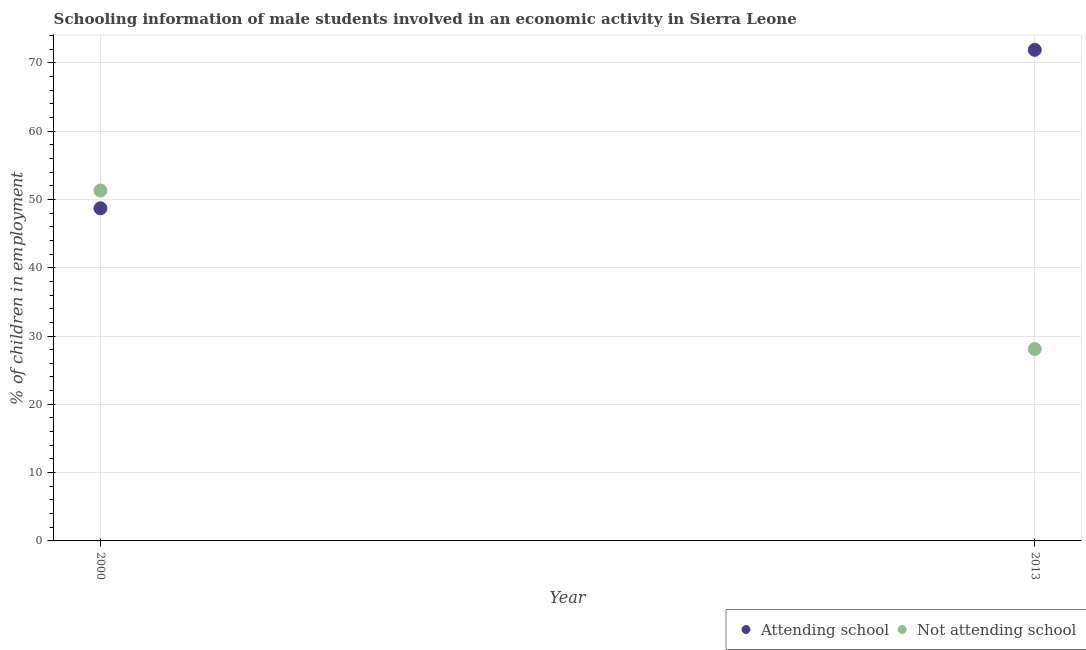How many different coloured dotlines are there?
Provide a succinct answer. 2. Is the number of dotlines equal to the number of legend labels?
Your response must be concise. Yes. What is the percentage of employed males who are attending school in 2000?
Make the answer very short. 48.7. Across all years, what is the maximum percentage of employed males who are attending school?
Ensure brevity in your answer.  71.9. Across all years, what is the minimum percentage of employed males who are attending school?
Provide a succinct answer. 48.7. In which year was the percentage of employed males who are not attending school minimum?
Your response must be concise. 2013. What is the total percentage of employed males who are not attending school in the graph?
Your response must be concise. 79.4. What is the difference between the percentage of employed males who are not attending school in 2000 and that in 2013?
Your answer should be very brief. 23.2. What is the difference between the percentage of employed males who are not attending school in 2013 and the percentage of employed males who are attending school in 2000?
Offer a very short reply. -20.6. What is the average percentage of employed males who are not attending school per year?
Your answer should be very brief. 39.7. In the year 2013, what is the difference between the percentage of employed males who are not attending school and percentage of employed males who are attending school?
Make the answer very short. -43.8. In how many years, is the percentage of employed males who are attending school greater than 10 %?
Give a very brief answer. 2. What is the ratio of the percentage of employed males who are attending school in 2000 to that in 2013?
Your response must be concise. 0.68. Is the percentage of employed males who are attending school in 2000 less than that in 2013?
Your answer should be compact. Yes. In how many years, is the percentage of employed males who are not attending school greater than the average percentage of employed males who are not attending school taken over all years?
Ensure brevity in your answer.  1. Is the percentage of employed males who are not attending school strictly greater than the percentage of employed males who are attending school over the years?
Your answer should be compact. No. Is the percentage of employed males who are attending school strictly less than the percentage of employed males who are not attending school over the years?
Your response must be concise. No. How many years are there in the graph?
Your response must be concise. 2. What is the difference between two consecutive major ticks on the Y-axis?
Your answer should be very brief. 10. Where does the legend appear in the graph?
Give a very brief answer. Bottom right. What is the title of the graph?
Provide a succinct answer. Schooling information of male students involved in an economic activity in Sierra Leone. What is the label or title of the Y-axis?
Make the answer very short. % of children in employment. What is the % of children in employment in Attending school in 2000?
Offer a very short reply. 48.7. What is the % of children in employment of Not attending school in 2000?
Your answer should be compact. 51.3. What is the % of children in employment of Attending school in 2013?
Your answer should be compact. 71.9. What is the % of children in employment in Not attending school in 2013?
Your response must be concise. 28.1. Across all years, what is the maximum % of children in employment in Attending school?
Keep it short and to the point. 71.9. Across all years, what is the maximum % of children in employment of Not attending school?
Give a very brief answer. 51.3. Across all years, what is the minimum % of children in employment of Attending school?
Ensure brevity in your answer.  48.7. Across all years, what is the minimum % of children in employment of Not attending school?
Your answer should be compact. 28.1. What is the total % of children in employment in Attending school in the graph?
Provide a succinct answer. 120.6. What is the total % of children in employment of Not attending school in the graph?
Your answer should be very brief. 79.4. What is the difference between the % of children in employment of Attending school in 2000 and that in 2013?
Your answer should be very brief. -23.2. What is the difference between the % of children in employment of Not attending school in 2000 and that in 2013?
Your answer should be very brief. 23.2. What is the difference between the % of children in employment of Attending school in 2000 and the % of children in employment of Not attending school in 2013?
Offer a very short reply. 20.6. What is the average % of children in employment in Attending school per year?
Your answer should be compact. 60.3. What is the average % of children in employment in Not attending school per year?
Your answer should be very brief. 39.7. In the year 2013, what is the difference between the % of children in employment of Attending school and % of children in employment of Not attending school?
Provide a short and direct response. 43.8. What is the ratio of the % of children in employment in Attending school in 2000 to that in 2013?
Make the answer very short. 0.68. What is the ratio of the % of children in employment of Not attending school in 2000 to that in 2013?
Ensure brevity in your answer.  1.83. What is the difference between the highest and the second highest % of children in employment in Attending school?
Give a very brief answer. 23.2. What is the difference between the highest and the second highest % of children in employment of Not attending school?
Provide a short and direct response. 23.2. What is the difference between the highest and the lowest % of children in employment of Attending school?
Keep it short and to the point. 23.2. What is the difference between the highest and the lowest % of children in employment in Not attending school?
Make the answer very short. 23.2. 